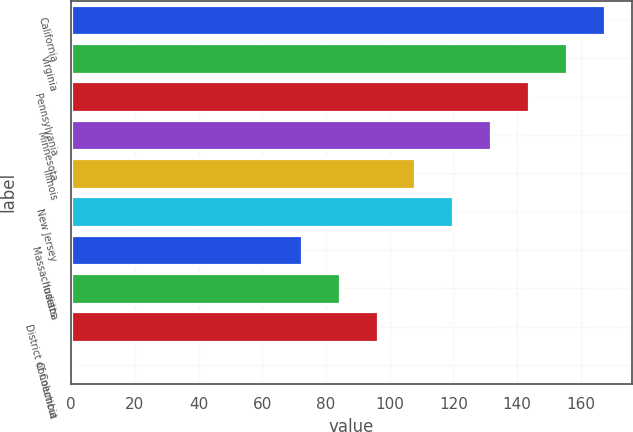<chart> <loc_0><loc_0><loc_500><loc_500><bar_chart><fcel>California<fcel>Virginia<fcel>Pennsylvania<fcel>Minnesota<fcel>Illinois<fcel>New Jersey<fcel>Massachusetts<fcel>Indiana<fcel>District of Columbia<fcel>Connecticut<nl><fcel>167.6<fcel>155.7<fcel>143.8<fcel>131.9<fcel>108.1<fcel>120<fcel>72.4<fcel>84.3<fcel>96.2<fcel>1<nl></chart> 